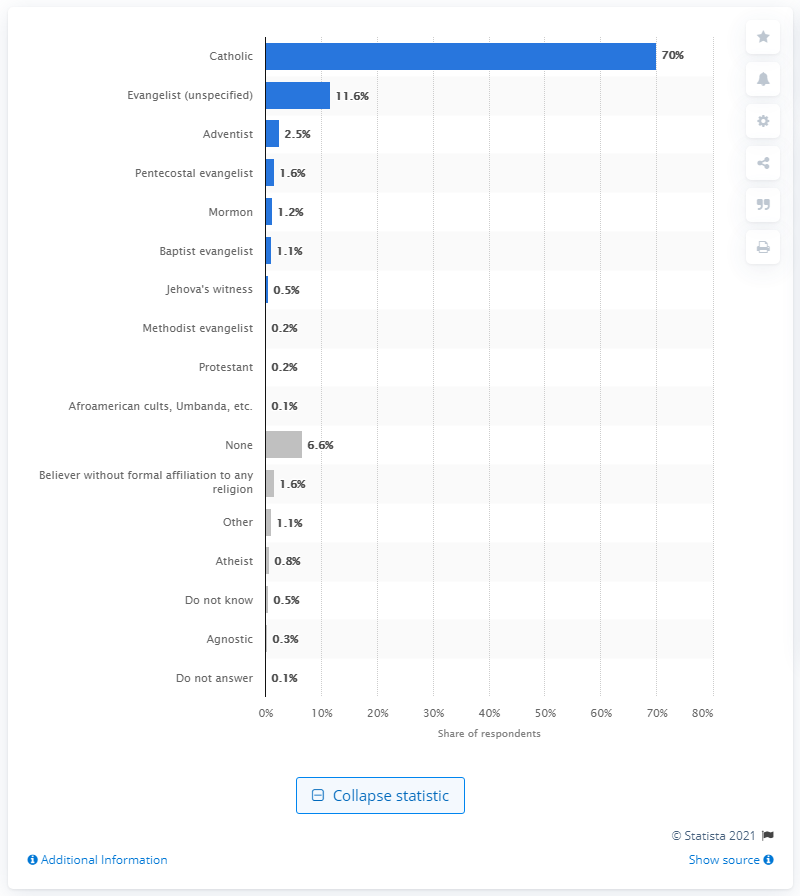Give some essential details in this illustration. According to a survey conducted in Bolivia, 0.8% of Bolivians identified as atheists. 